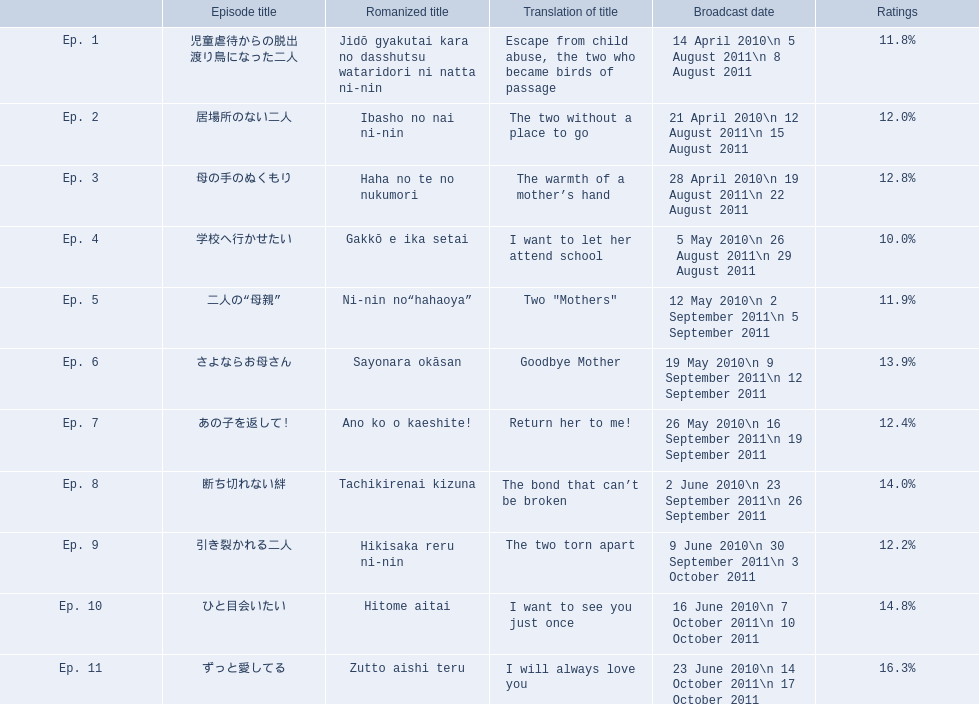How many total episodes are there? Ep. 1, Ep. 2, Ep. 3, Ep. 4, Ep. 5, Ep. 6, Ep. 7, Ep. 8, Ep. 9, Ep. 10, Ep. 11. Of those episodes, which one has the title of the bond that can't be broken? Ep. 8. What was the ratings percentage for that episode? 14.0%. 